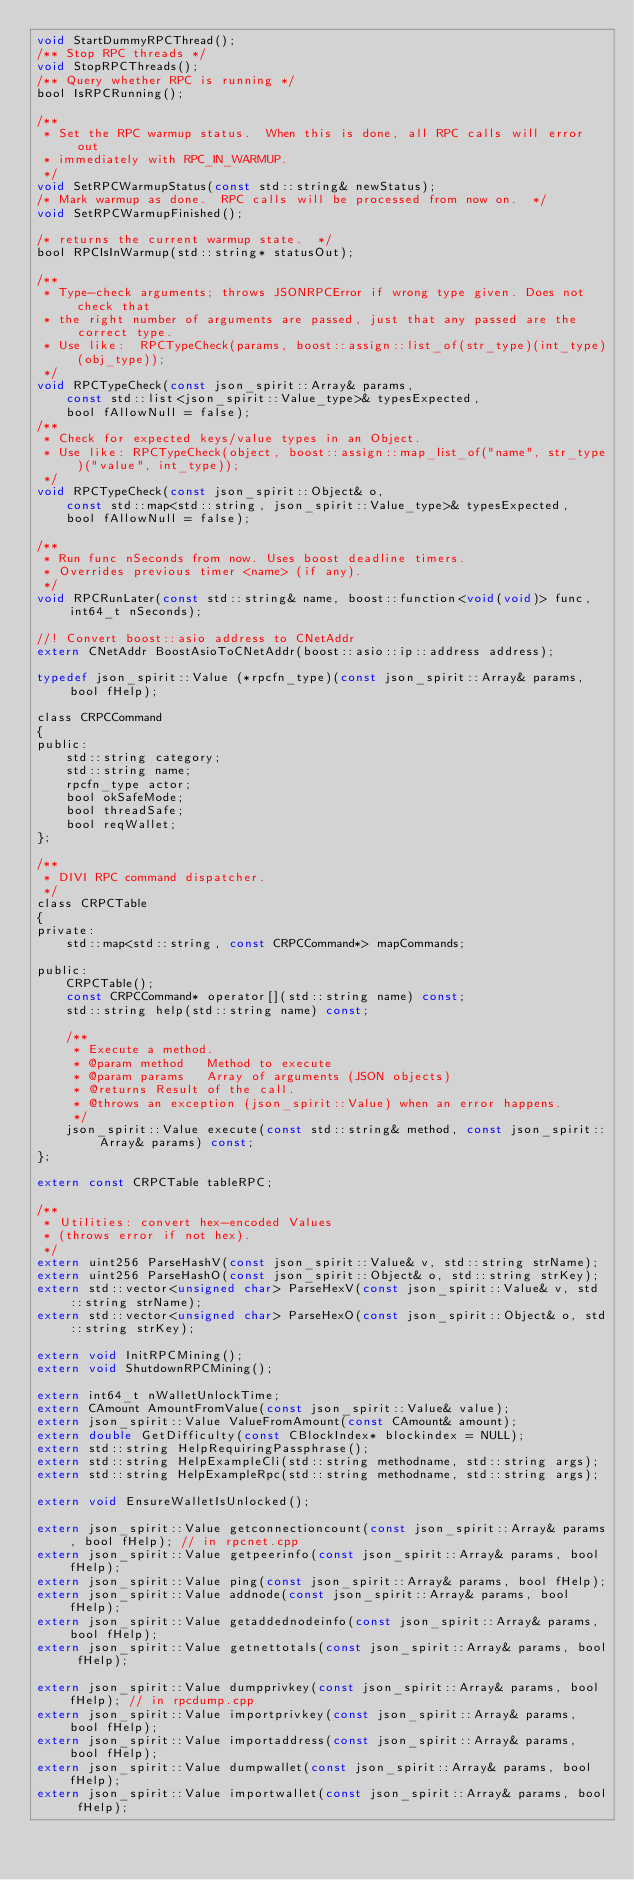Convert code to text. <code><loc_0><loc_0><loc_500><loc_500><_C_>void StartDummyRPCThread();
/** Stop RPC threads */
void StopRPCThreads();
/** Query whether RPC is running */
bool IsRPCRunning();

/** 
 * Set the RPC warmup status.  When this is done, all RPC calls will error out
 * immediately with RPC_IN_WARMUP.
 */
void SetRPCWarmupStatus(const std::string& newStatus);
/* Mark warmup as done.  RPC calls will be processed from now on.  */
void SetRPCWarmupFinished();

/* returns the current warmup state.  */
bool RPCIsInWarmup(std::string* statusOut);

/**
 * Type-check arguments; throws JSONRPCError if wrong type given. Does not check that
 * the right number of arguments are passed, just that any passed are the correct type.
 * Use like:  RPCTypeCheck(params, boost::assign::list_of(str_type)(int_type)(obj_type));
 */
void RPCTypeCheck(const json_spirit::Array& params,
    const std::list<json_spirit::Value_type>& typesExpected,
    bool fAllowNull = false);
/**
 * Check for expected keys/value types in an Object.
 * Use like: RPCTypeCheck(object, boost::assign::map_list_of("name", str_type)("value", int_type));
 */
void RPCTypeCheck(const json_spirit::Object& o,
    const std::map<std::string, json_spirit::Value_type>& typesExpected,
    bool fAllowNull = false);

/**
 * Run func nSeconds from now. Uses boost deadline timers.
 * Overrides previous timer <name> (if any).
 */
void RPCRunLater(const std::string& name, boost::function<void(void)> func, int64_t nSeconds);

//! Convert boost::asio address to CNetAddr
extern CNetAddr BoostAsioToCNetAddr(boost::asio::ip::address address);

typedef json_spirit::Value (*rpcfn_type)(const json_spirit::Array& params, bool fHelp);

class CRPCCommand
{
public:
    std::string category;
    std::string name;
    rpcfn_type actor;
    bool okSafeMode;
    bool threadSafe;
    bool reqWallet;
};

/**
 * DIVI RPC command dispatcher.
 */
class CRPCTable
{
private:
    std::map<std::string, const CRPCCommand*> mapCommands;

public:
    CRPCTable();
    const CRPCCommand* operator[](std::string name) const;
    std::string help(std::string name) const;

    /**
     * Execute a method.
     * @param method   Method to execute
     * @param params   Array of arguments (JSON objects)
     * @returns Result of the call.
     * @throws an exception (json_spirit::Value) when an error happens.
     */
    json_spirit::Value execute(const std::string& method, const json_spirit::Array& params) const;
};

extern const CRPCTable tableRPC;

/**
 * Utilities: convert hex-encoded Values
 * (throws error if not hex).
 */
extern uint256 ParseHashV(const json_spirit::Value& v, std::string strName);
extern uint256 ParseHashO(const json_spirit::Object& o, std::string strKey);
extern std::vector<unsigned char> ParseHexV(const json_spirit::Value& v, std::string strName);
extern std::vector<unsigned char> ParseHexO(const json_spirit::Object& o, std::string strKey);

extern void InitRPCMining();
extern void ShutdownRPCMining();

extern int64_t nWalletUnlockTime;
extern CAmount AmountFromValue(const json_spirit::Value& value);
extern json_spirit::Value ValueFromAmount(const CAmount& amount);
extern double GetDifficulty(const CBlockIndex* blockindex = NULL);
extern std::string HelpRequiringPassphrase();
extern std::string HelpExampleCli(std::string methodname, std::string args);
extern std::string HelpExampleRpc(std::string methodname, std::string args);

extern void EnsureWalletIsUnlocked();

extern json_spirit::Value getconnectioncount(const json_spirit::Array& params, bool fHelp); // in rpcnet.cpp
extern json_spirit::Value getpeerinfo(const json_spirit::Array& params, bool fHelp);
extern json_spirit::Value ping(const json_spirit::Array& params, bool fHelp);
extern json_spirit::Value addnode(const json_spirit::Array& params, bool fHelp);
extern json_spirit::Value getaddednodeinfo(const json_spirit::Array& params, bool fHelp);
extern json_spirit::Value getnettotals(const json_spirit::Array& params, bool fHelp);

extern json_spirit::Value dumpprivkey(const json_spirit::Array& params, bool fHelp); // in rpcdump.cpp
extern json_spirit::Value importprivkey(const json_spirit::Array& params, bool fHelp);
extern json_spirit::Value importaddress(const json_spirit::Array& params, bool fHelp);
extern json_spirit::Value dumpwallet(const json_spirit::Array& params, bool fHelp);
extern json_spirit::Value importwallet(const json_spirit::Array& params, bool fHelp);</code> 